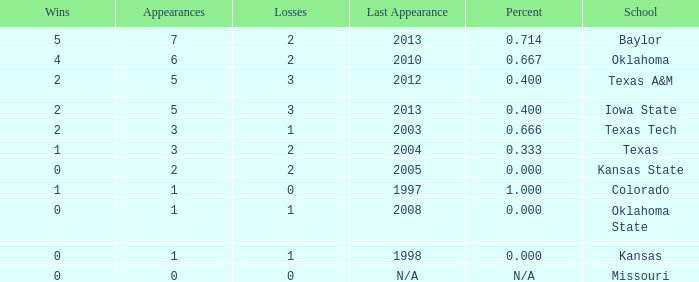What's the largest amount of wins Texas has?  1.0. 